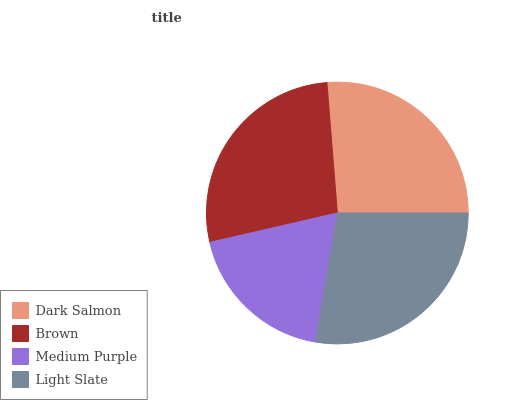Is Medium Purple the minimum?
Answer yes or no. Yes. Is Light Slate the maximum?
Answer yes or no. Yes. Is Brown the minimum?
Answer yes or no. No. Is Brown the maximum?
Answer yes or no. No. Is Brown greater than Dark Salmon?
Answer yes or no. Yes. Is Dark Salmon less than Brown?
Answer yes or no. Yes. Is Dark Salmon greater than Brown?
Answer yes or no. No. Is Brown less than Dark Salmon?
Answer yes or no. No. Is Brown the high median?
Answer yes or no. Yes. Is Dark Salmon the low median?
Answer yes or no. Yes. Is Dark Salmon the high median?
Answer yes or no. No. Is Medium Purple the low median?
Answer yes or no. No. 